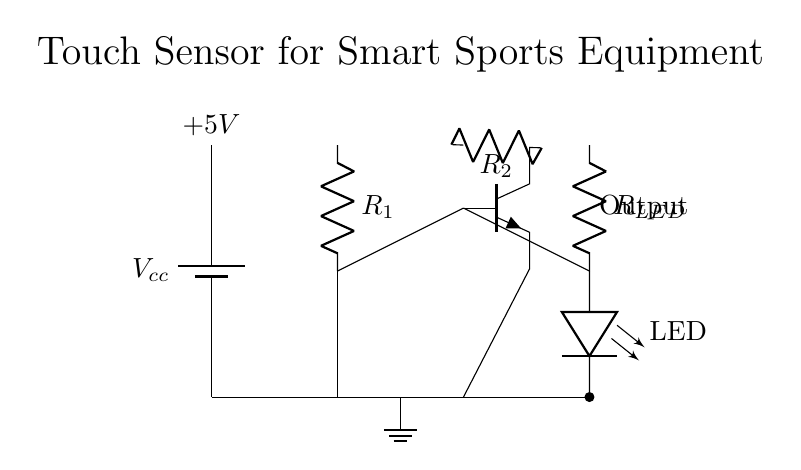What is the main power supply of this circuit? The power supply is represented by the battery symbol, which provides a voltage of 5V to the circuit.
Answer: 5V What type of sensor is used in this circuit? The circuit shows a generic touch sensor, indicated by the label next to it. This sensor detects touch input.
Answer: Touch sensor What component is used to amplify the signal in this circuit? The transistor depicted in the circuit diagram amplifies the input signal from the touch sensor, transforming it for further processing.
Answer: Transistor What would happen if R1 is removed? Removing R1 would cause no current to flow to the base of the transistor, preventing it from turning on, which would deactivate the output (LED).
Answer: LED off How does the output connect to the transistor? The output connected to the LED links back to the collector (C) of the transistor, which allows the amplified current to flow through it when the sensor is activated.
Answer: Collector to LED What is the purpose of R2 in this circuit? R2 serves as a current limiting resistor for the transistor; it controls the amount of current flowing to the collector and thus into the LED to prevent damage.
Answer: Current limiting resistor What happens when the touch sensor is activated? When the touch sensor is activated, it allows current to flow to the base of the transistor, turning it on. Consequently, current flows through R2 and powers the LED, causing it to light up.
Answer: LED lights up 